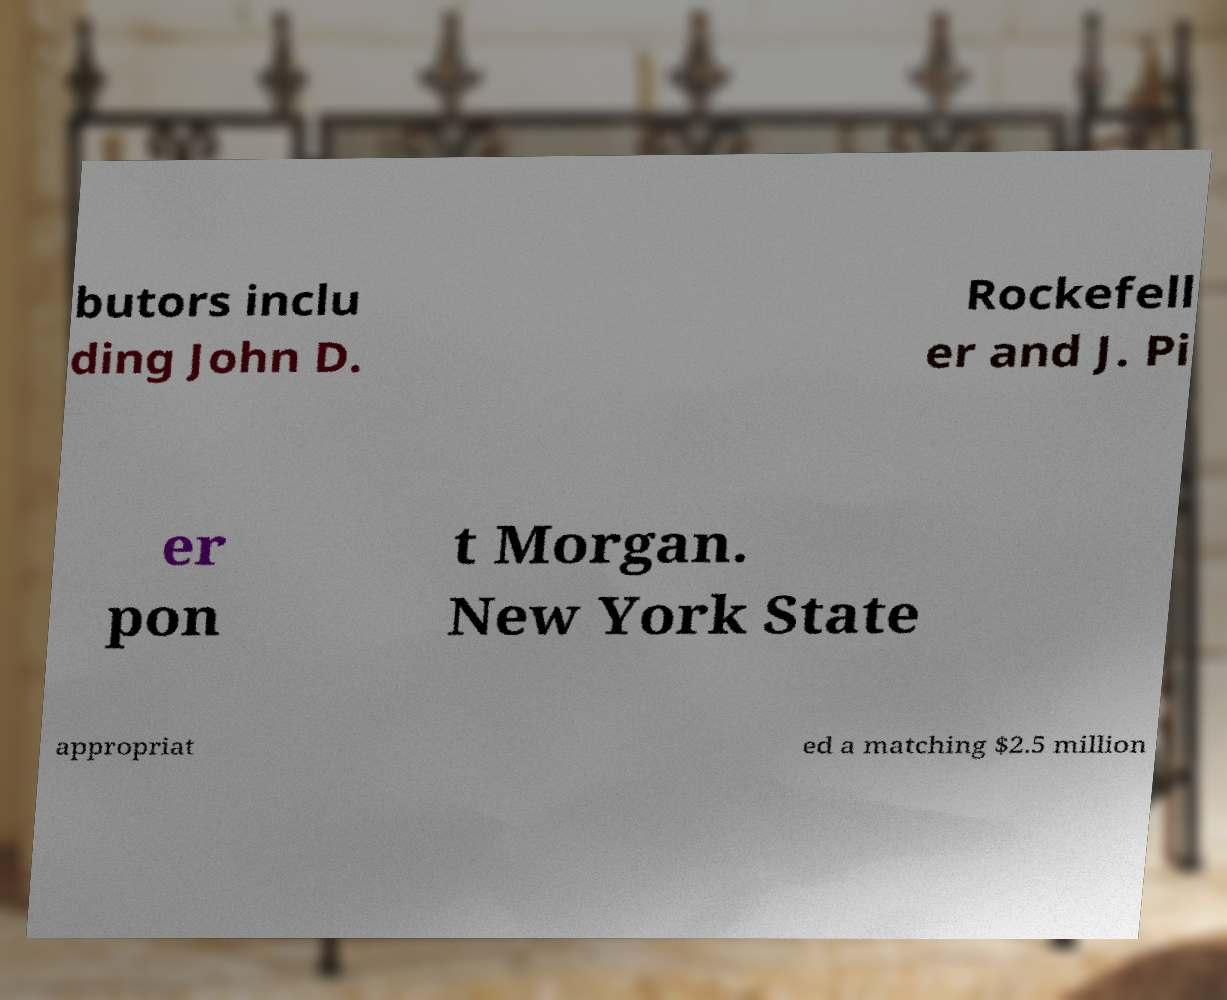Please identify and transcribe the text found in this image. butors inclu ding John D. Rockefell er and J. Pi er pon t Morgan. New York State appropriat ed a matching $2.5 million 